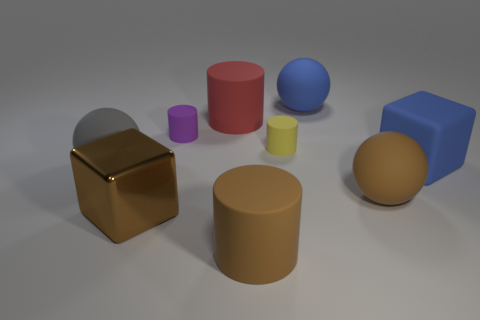Subtract 1 cylinders. How many cylinders are left? 3 Add 1 shiny objects. How many objects exist? 10 Subtract all balls. How many objects are left? 6 Subtract all large matte spheres. Subtract all large blue rubber blocks. How many objects are left? 5 Add 3 blue blocks. How many blue blocks are left? 4 Add 4 big metal things. How many big metal things exist? 5 Subtract 0 cyan cylinders. How many objects are left? 9 